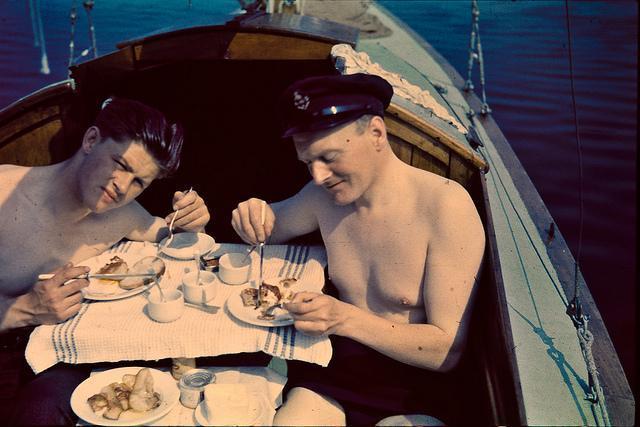Does the image validate the caption "The dining table is away from the boat."?
Answer yes or no. No. Is the caption "The boat is behind the dining table." a true representation of the image?
Answer yes or no. No. Is the given caption "The dining table is on the boat." fitting for the image?
Answer yes or no. Yes. Is the given caption "The boat is beneath the dining table." fitting for the image?
Answer yes or no. Yes. Evaluate: Does the caption "The boat is attached to the dining table." match the image?
Answer yes or no. No. Evaluate: Does the caption "The dining table is within the boat." match the image?
Answer yes or no. Yes. 